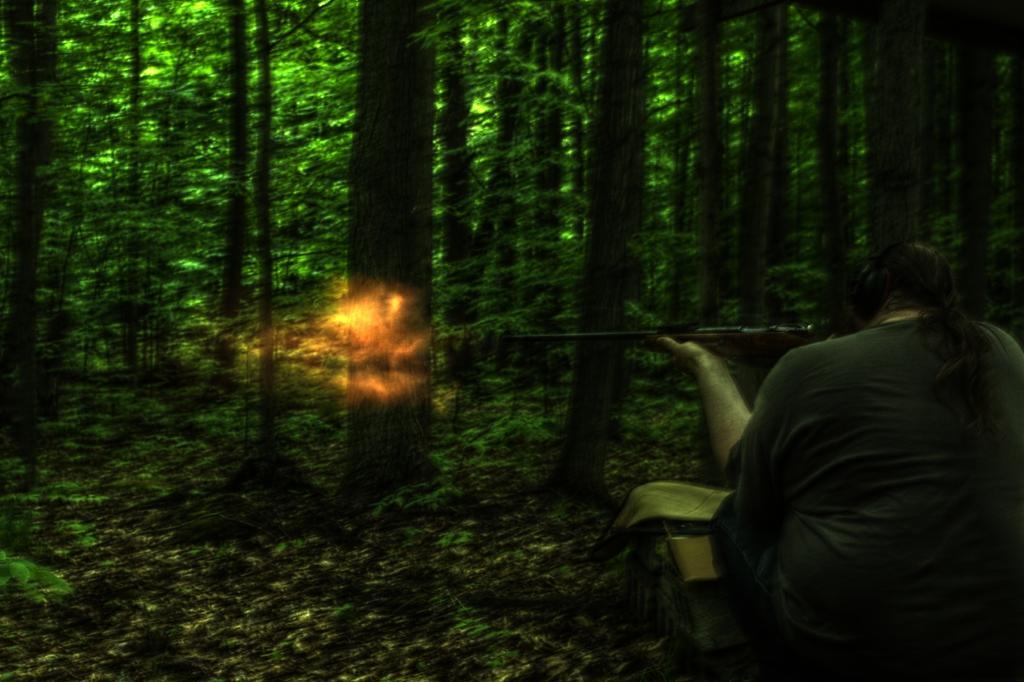Please provide a concise description of this image. In this image we can see a person holding the gun and firing. In the background we can see many trees and at the bottom we can see the dried leaves on the ground. 